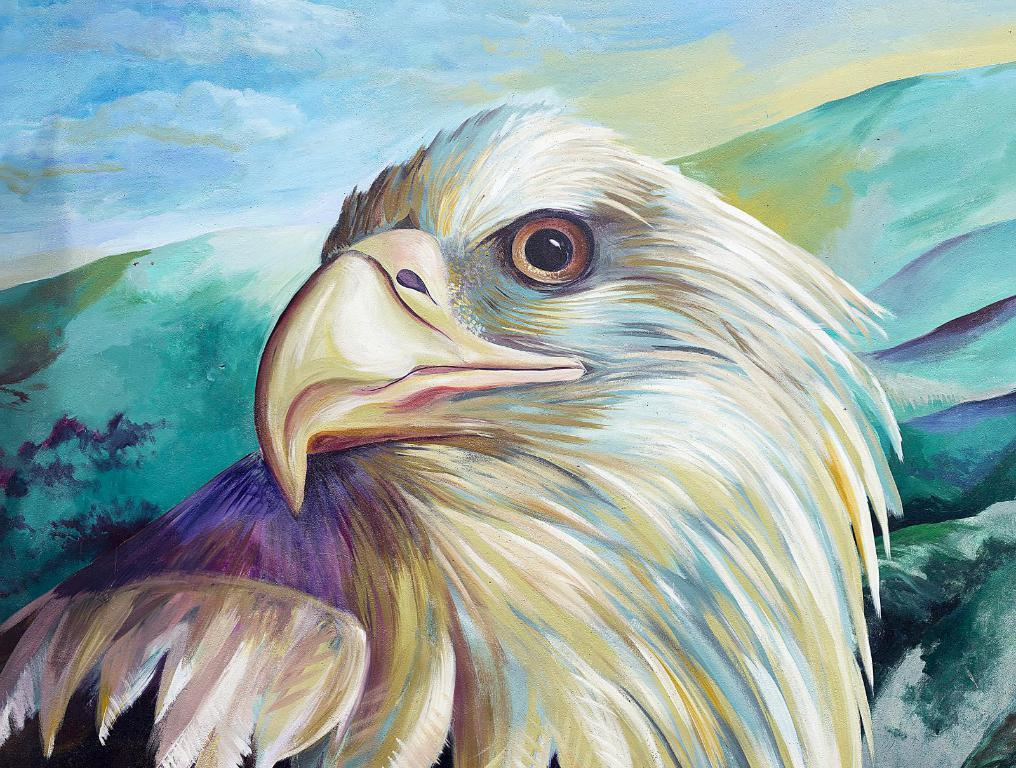What is the main subject of the painting in the image? The painting depicts an eagle. Are there any other elements in the painting besides the eagle? Yes, the painting also includes clouds. What type of stove is visible in the painting? There is no stove present in the painting; it features an eagle and clouds. 